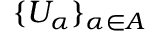<formula> <loc_0><loc_0><loc_500><loc_500>\{ U _ { \alpha } \} _ { \alpha \in A }</formula> 